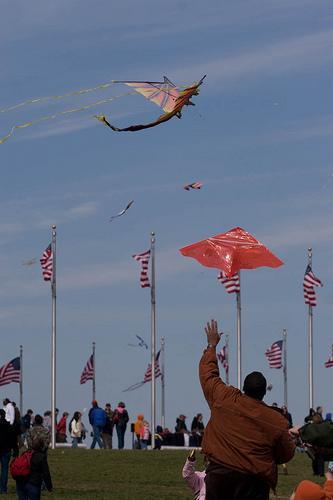How many flags are shown?
Give a very brief answer. 9. How many people can you see?
Give a very brief answer. 2. 